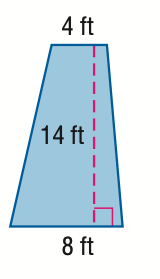Answer the mathemtical geometry problem and directly provide the correct option letter.
Question: Find the area of the trapezoid.
Choices: A: 28 B: 42 C: 84 D: 168 C 